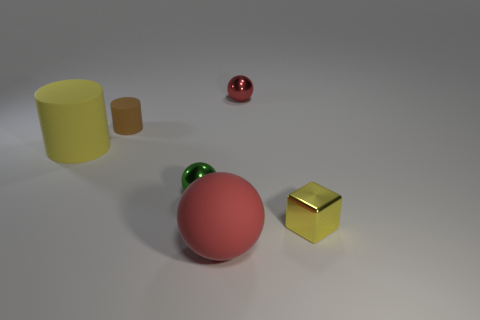Add 4 tiny brown rubber objects. How many objects exist? 10 Subtract all cylinders. How many objects are left? 4 Subtract 1 brown cylinders. How many objects are left? 5 Subtract all tiny yellow metallic objects. Subtract all tiny yellow cubes. How many objects are left? 4 Add 1 small brown rubber cylinders. How many small brown rubber cylinders are left? 2 Add 4 big rubber spheres. How many big rubber spheres exist? 5 